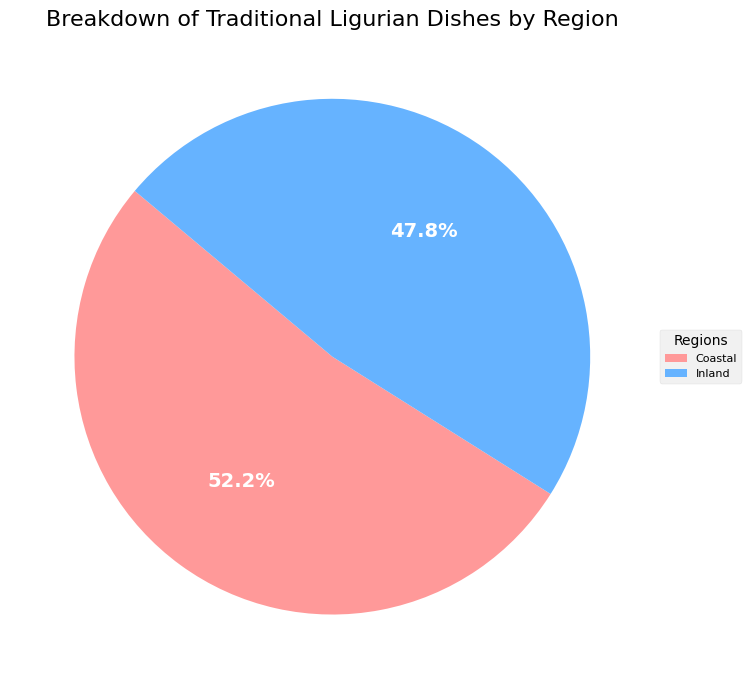What percentage of traditional Ligurian dishes come from the coastal region? The pie chart indicates a sector representing the coastal region. This sector is labeled with the percentage of traditional Ligurian dishes attributed specifically to this area.
Answer: 54.5% How many traditional Ligurian dishes come from the inland region? The pie chart shows the total percentages for both regions. Initially, we must determine the total number of dishes from the dataset. Adding the counts for inland dishes: 11 + 13 + 9 + 7 + 5 + 6 + 4 = 55.
Answer: 55 Which region has more traditional Ligurian dishes? The pie chart shows the portion sizes for the coastal and inland regions. Comparing the sizes, the coastal segment is observed to be slightly larger. Thus, it represents a higher count of dishes.
Answer: Coastal What is the numerical difference in the count of traditional dishes between the coastal and inland regions? From the provided dataset, we sum up the counts for each region. Coastal: 15 + 12 + 10 + 8 + 9 + 6 = 60; Inland: 11 + 13 + 9 + 7 + 5 + 6 + 4 = 55. The difference is 60 - 55.
Answer: 5 Is the proportion of traditional Ligurian dishes higher on the coast or inland? By examining the pie chart, we are able to visually confirm that the coastal region has a larger segment compared to the inland presence. This confirms a higher proportion of dishes in the coastal region.
Answer: Coastal If a new inland dish was added, making it 12 inland dishes, how would the percentage change? Initially, Coastal: 60 dishes, Inland: 55 dishes. Adding one more dish to the inland: 55 + 1 = 56. New total = 60 + 56 = 116. New inland percentage = (56/116) * 100.
Answer: 48.3% In the current dataset, what is the approximate ratio of coastal to inland traditional Ligurian dishes? From the dataset, coast counts are 60, and inland counts are 55. The ratio of coastal to inland is 60 to 55, which simplifies to approximately 12 to 11 when divided by their GCD of 5.
Answer: 12:11 What is the sum of the percentages of dishes from both regions? From the pie chart, the displayed percentages for coastal and inland regions sum up exactly to 100%.
Answer: 100% 